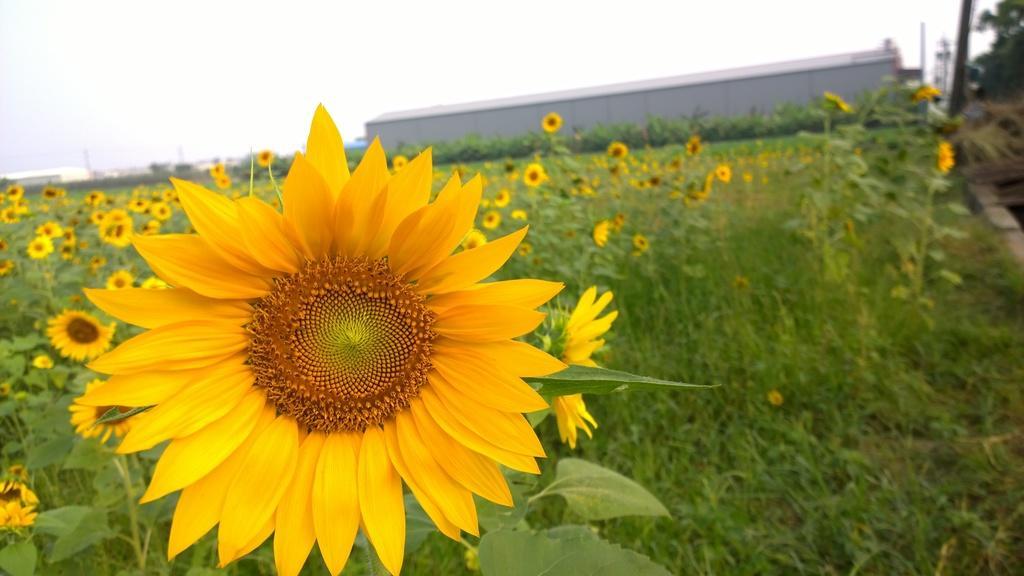Please provide a concise description of this image. In front of the image there is sunflower, behind that there are sun flower plants with flowers and leaves, in the background of the image there are metal sheds, electric poles and trees. 